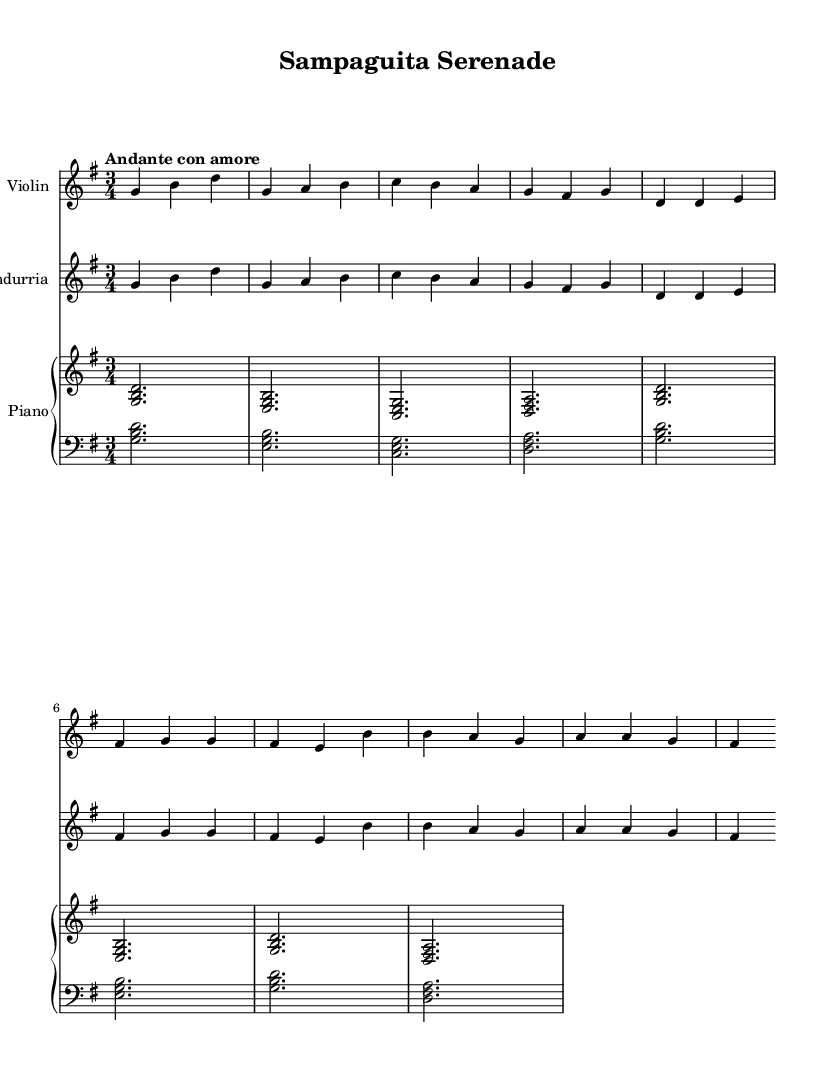What is the key signature of this music? The key signature is G major, which has one sharp (F#). This is determined by looking at the key signature indicated at the beginning of the staff, which shows the sharp symbol on the line that corresponds to F.
Answer: G major What is the time signature of this music? The time signature is 3/4, as indicated at the beginning of the sheet music. This means there are three beats in a measure, and the quarter note gets one beat.
Answer: 3/4 What is the tempo marking of this piece? The tempo marking is "Andante con amore," which indicates a moderately slow pace with a loving feel. This can be found below the title of the piece.
Answer: Andante con amore How many measures are in the chorus? The chorus consists of two measures, as indicated by the notation, which shows the musical content comprising b' b a g and a a g fis within two bar lines.
Answer: 2 What type of instrument is the bandurria? The bandurria is a string instrument, typically used in traditional Filipino music. In this piece, it plays a similar role to the violin, providing melodic lines. This is based on the context of the sheet music indicating it as one of the instruments.
Answer: String instrument Which instruments are featured in the score? The instruments featured in the score are the Violin, Bandurria, and Piano. Each is indicated at the beginning of its respective staff in the score layout.
Answer: Violin, Bandurria, Piano How does the melody of the violin relate to the bandurria in this piece? The melody of the violin and the bandurria is identical, as noted in their respective parts; they both play the same sequences of notes throughout the intro, verse, and chorus sections. This demonstrates a fusion of traditional and modern elements.
Answer: Identical melody 